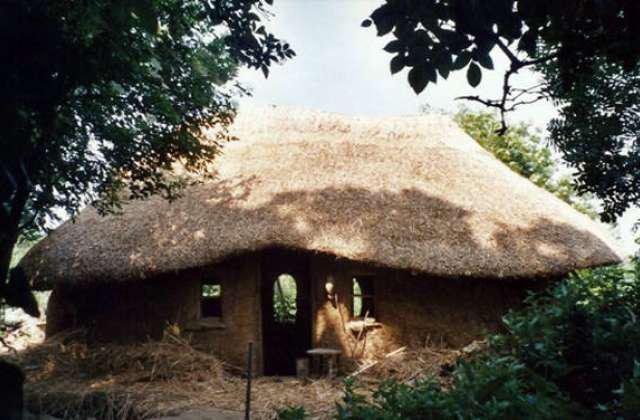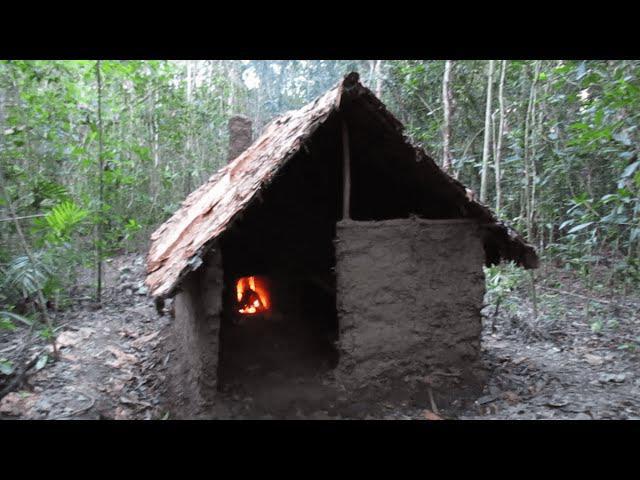The first image is the image on the left, the second image is the image on the right. Considering the images on both sides, is "In at least one of the images you can see all the way through the house to the outside." valid? Answer yes or no. Yes. 